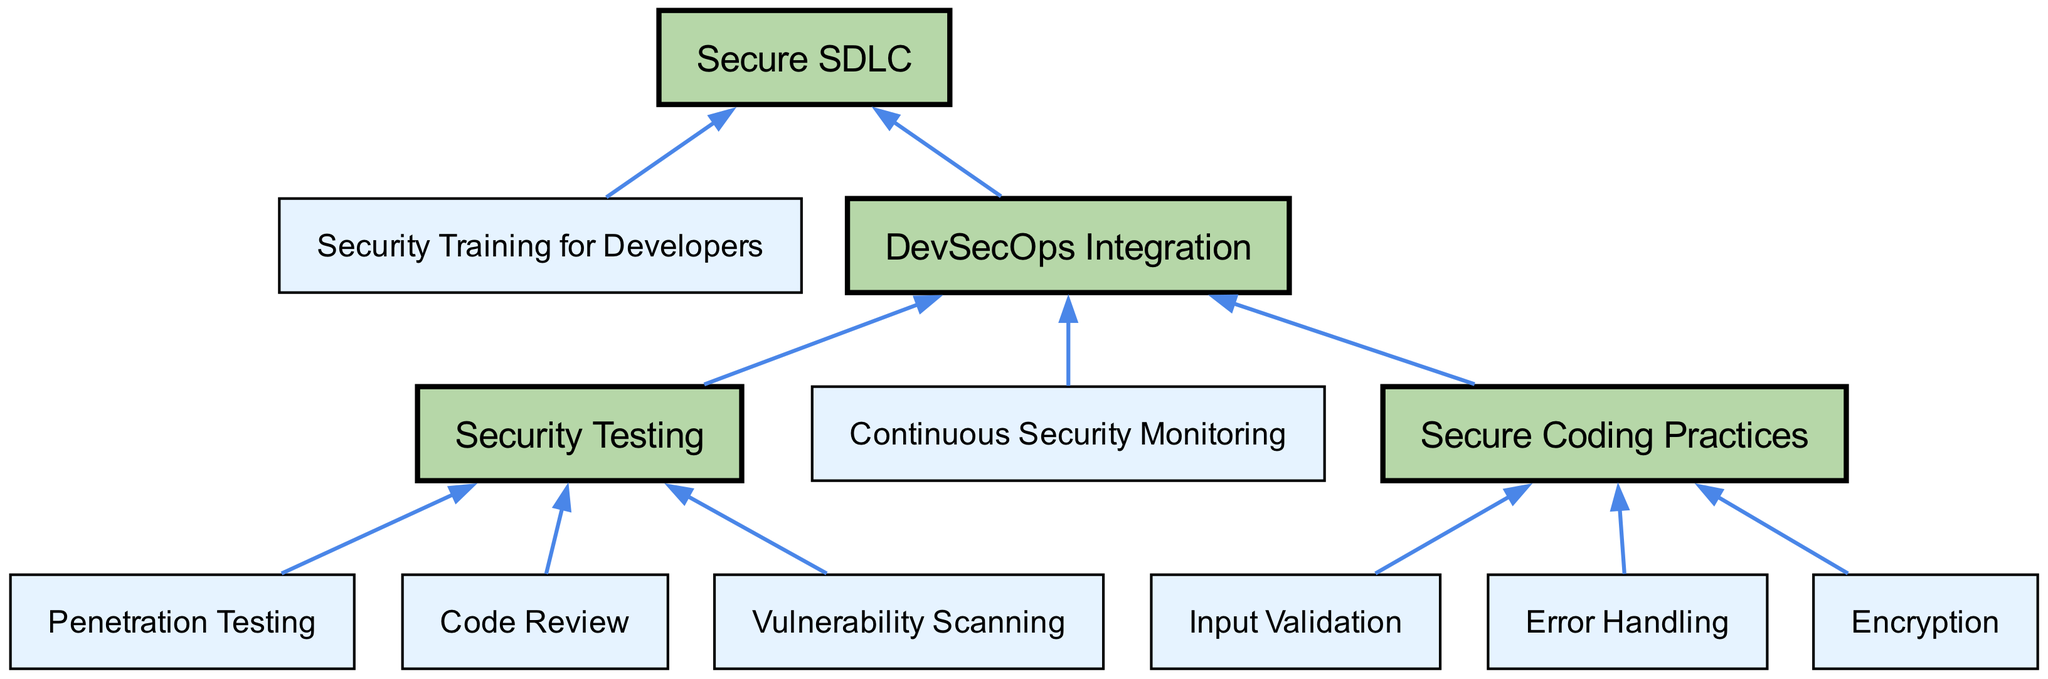What is the top-level node in the diagram? The top-level node is 'Secure SDLC', which denotes the overarching structure representing the secure software development lifecycle. It is the first node that has two child nodes, indicating an organized flow starting from it.
Answer: Secure SDLC How many main child nodes does 'Secure Coding Practices' have? 'Secure Coding Practices' has three child nodes: 'Input Validation', 'Error Handling', and 'Encryption'. This is based on the information directly branching from the 'Secure Coding Practices' node in the diagram.
Answer: 3 Which node is directly beneath 'DevSecOps Integration'? The node directly beneath 'DevSecOps Integration' is 'Continuous Security Monitoring'. This can be observed as 'Continuous Security Monitoring' is one of the child nodes of 'DevSecOps Integration'.
Answer: Continuous Security Monitoring What is the relationship between 'Security Testing' and 'Secure SDLC'? 'Security Testing' is a child node of 'Secure SDLC', indicating that it is a component of the secure software development lifecycle structure. The diagram outlines a hierarchy where 'Security Testing' contributes to the overall objectives of 'Secure SDLC'.
Answer: Child Name one type of security testing listed in the diagram. One type of security testing listed is 'Penetration Testing'. This is a direct child of 'Security Testing', showcasing one of the various methods for ensuring security in the development process.
Answer: Penetration Testing What are the two main components under 'Secure SDLC'? The two main components under 'Secure SDLC' are 'DevSecOps Integration' and 'Security Training for Developers'. These are the two child nodes that significantly contribute to the secure software development lifecycle framework.
Answer: DevSecOps Integration, Security Training for Developers How many security testing methods are represented in the diagram? There are three security testing methods represented: 'Penetration Testing', 'Code Review', and 'Vulnerability Scanning'. All of these are child nodes of 'Security Testing', depicting a range of security evaluation techniques.
Answer: 3 Which node is an example of a secure coding practice? An example of a secure coding practice is 'Input Validation'. This is one of the specific practices listed as a child of 'Secure Coding Practices', emphasizing its importance in the coding phase.
Answer: Input Validation 